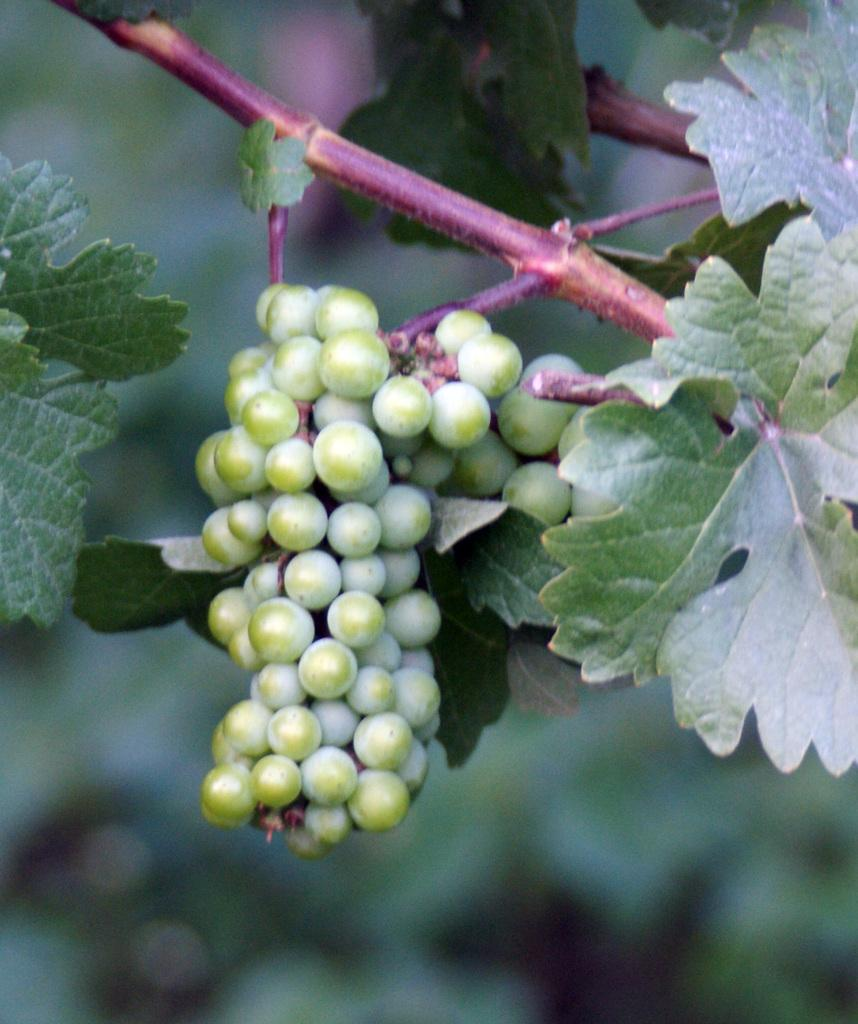What type of fruit is visible in the image? There is a bunch of grapes in the image. What part of the grapes is connected to the stem? The bunch of grapes has a stem. What else is attached to the grapes besides the stem? The bunch of grapes has leaves. What can be seen in the background of the image? There is greenery visible in the background of the image. What type of chess piece is located on the left side of the image? There is no chess piece present in the image; it features a bunch of grapes with a stem and leaves. How many women are visible in the image? There are no women present in the image; it features a bunch of grapes with a stem and leaves. 